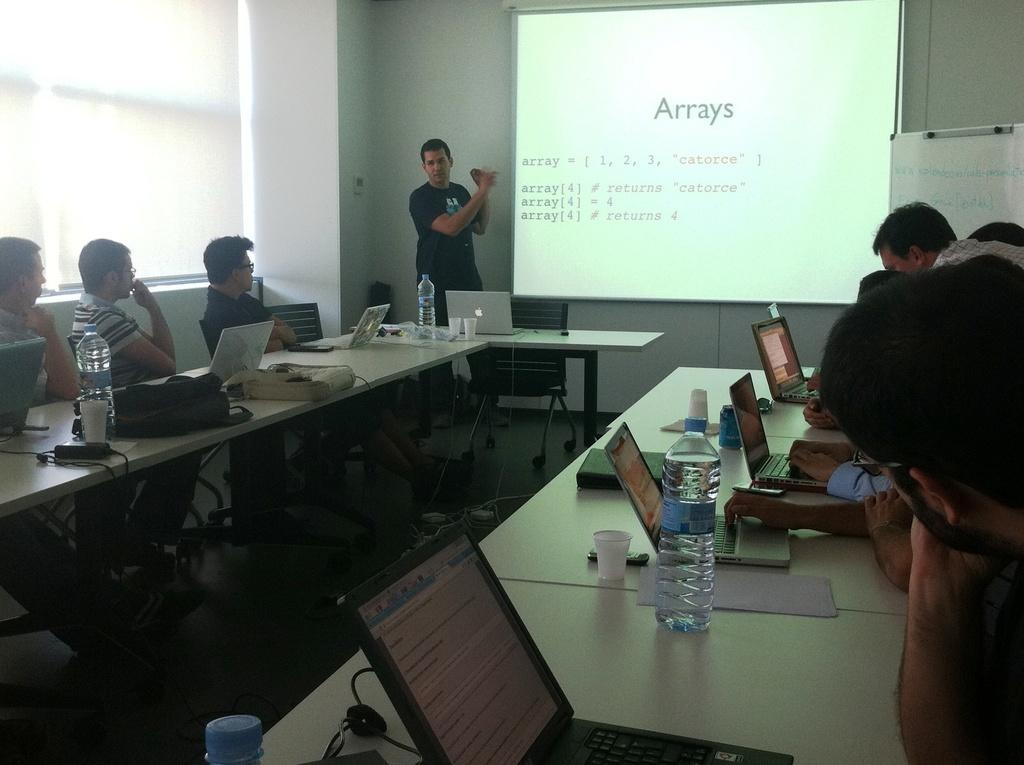<image>
Render a clear and concise summary of the photo. Man giving a presentation with a screen that says Arrays on it. 